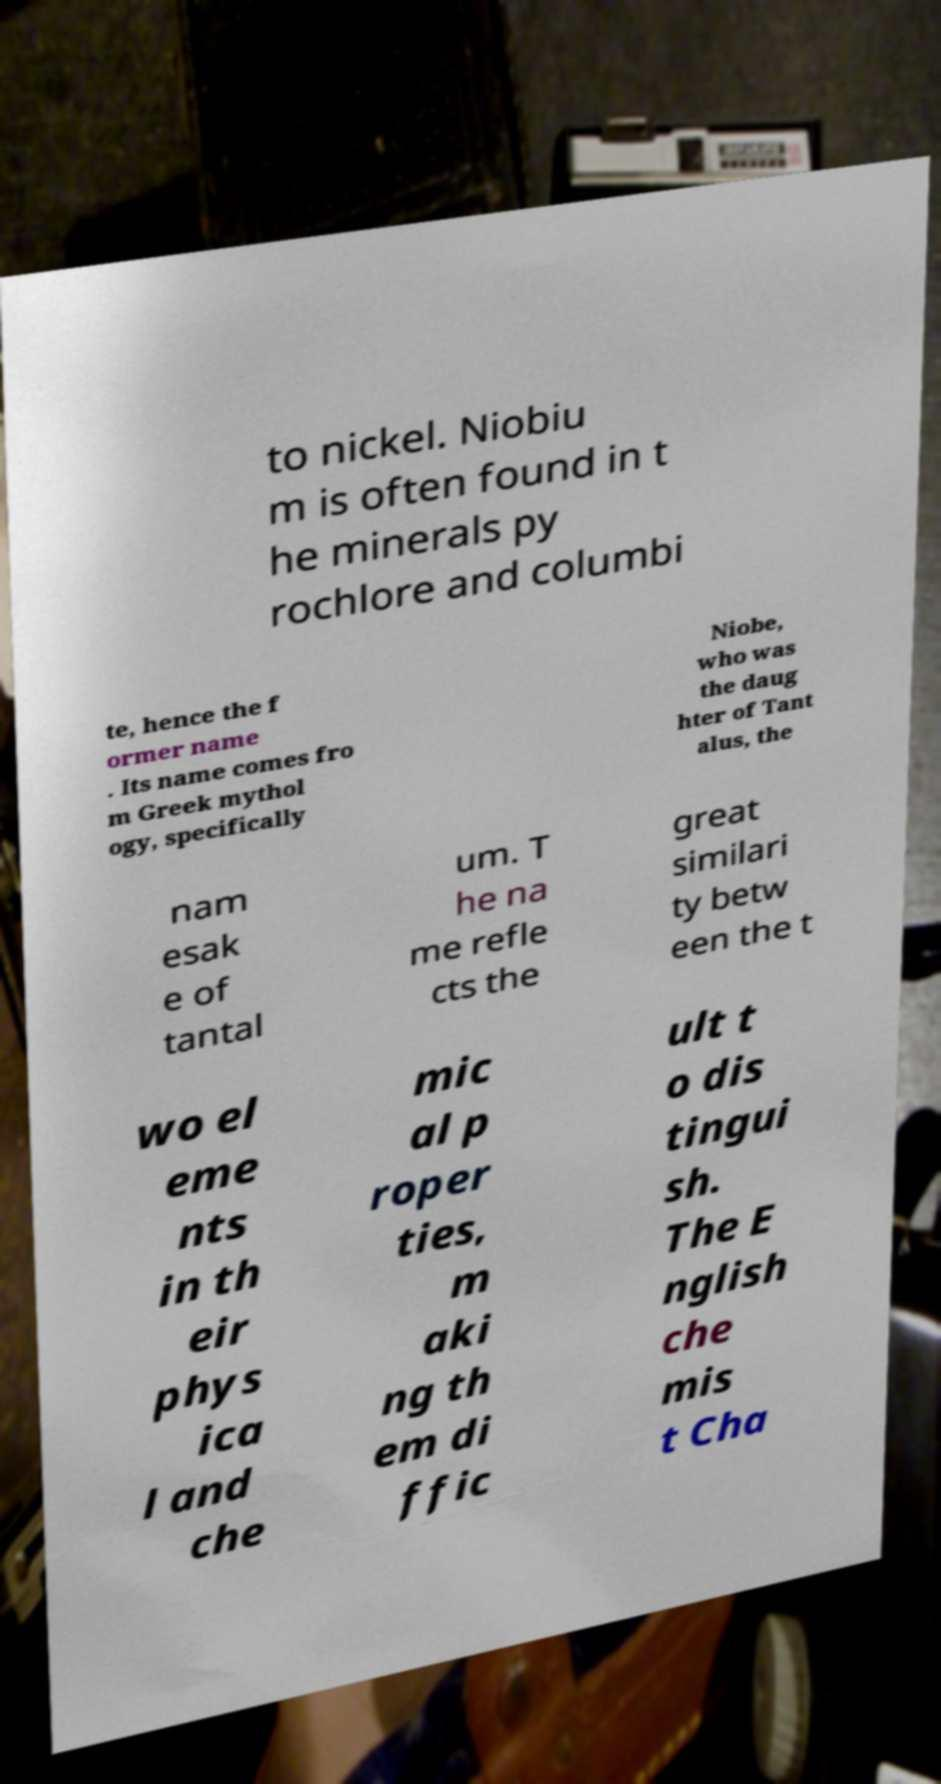There's text embedded in this image that I need extracted. Can you transcribe it verbatim? to nickel. Niobiu m is often found in t he minerals py rochlore and columbi te, hence the f ormer name . Its name comes fro m Greek mythol ogy, specifically Niobe, who was the daug hter of Tant alus, the nam esak e of tantal um. T he na me refle cts the great similari ty betw een the t wo el eme nts in th eir phys ica l and che mic al p roper ties, m aki ng th em di ffic ult t o dis tingui sh. The E nglish che mis t Cha 